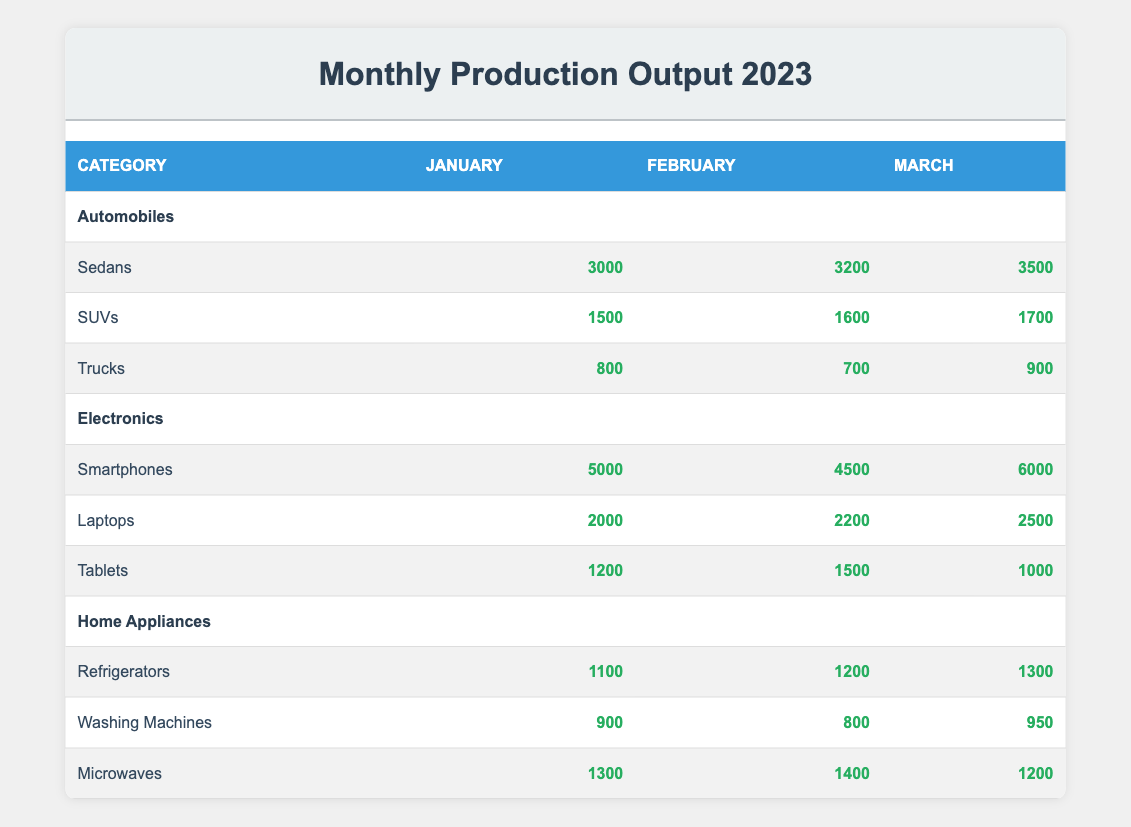What is the total production output for SUVs in January? The table shows that in January, the production output for SUVs is 1500. This is a specific retrieval question asking for the value listed under the SUV category for January.
Answer: 1500 How many more smartphones were produced in March compared to February? In March, 6000 smartphones were produced, while in February, 4500 smartphones were produced. To find the difference, subtract the February output from the March output: 6000 - 4500 = 1500.
Answer: 1500 Did the production of washing machines increase in February compared to January? The table shows that 900 washing machines were produced in January and 800 in February. Since 800 is less than 900, this means production did not increase.
Answer: No What was the average production output of trucks across all three months? To calculate the average output for trucks, first sum the monthly outputs: January (800) + February (700) + March (900) = 2400. Then, divide this total by the number of months (3): 2400/3 = 800.
Answer: 800 Which category had the highest total production output in February and what was the total? First, find the total production for each category in February: Automobiles (3200 + 1600 + 700 = 5500), Electronics (4500 + 2200 + 1500 = 8200), Home Appliances (1200 + 800 + 1400 = 3400). The highest is Electronics with a total of 8200.
Answer: Electronics, 8200 In which month did refrigerators have the highest production output and what was that output? The production outputs for refrigerators are 1100 in January, 1200 in February, and 1300 in March. The highest value is in March when there were 1300 refrigerators produced.
Answer: March, 1300 How did the production of tablets change from January to March? In January, 1200 tablets were produced, and in March, only 1000 were produced. To determine how it changed, note that there was a decrease: 1000 - 1200 = -200.
Answer: Decrease by 200 What is the total production output for all product types in January? To find the total output for January, sum the production outputs for all categories: Automobiles (3000 + 1500 + 800 = 5300) + Electronics (5000 + 2000 + 1200 = 8200) + Home Appliances (1100 + 900 + 1300 = 3300) = 5300 + 8200 + 3300 = 16800.
Answer: 16800 Is the production of SUVs consistent across the three months? The production numbers for SUVs are 1500 in January, 1600 in February, and 1700 in March, indicating a consistent increase. Therefore, the output is not consistent but shows a trend.
Answer: No 